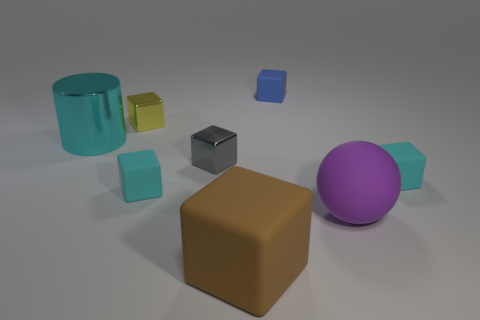What number of large things are either gray metallic things or cyan things?
Provide a succinct answer. 1. Do the tiny matte thing that is on the right side of the tiny blue thing and the tiny blue rubber object have the same shape?
Give a very brief answer. Yes. Is the number of rubber things less than the number of purple shiny objects?
Offer a terse response. No. Is there any other thing that has the same color as the ball?
Offer a terse response. No. The big object that is on the left side of the tiny yellow object has what shape?
Keep it short and to the point. Cylinder. There is a big shiny cylinder; is its color the same as the small rubber block to the left of the gray block?
Your response must be concise. Yes. Is the number of small yellow things that are to the left of the cylinder the same as the number of small cyan matte blocks that are behind the tiny yellow shiny block?
Keep it short and to the point. Yes. What number of other things are there of the same size as the brown cube?
Offer a very short reply. 2. What is the size of the cyan metal cylinder?
Give a very brief answer. Large. Does the large purple object have the same material as the big thing that is left of the brown object?
Make the answer very short. No. 